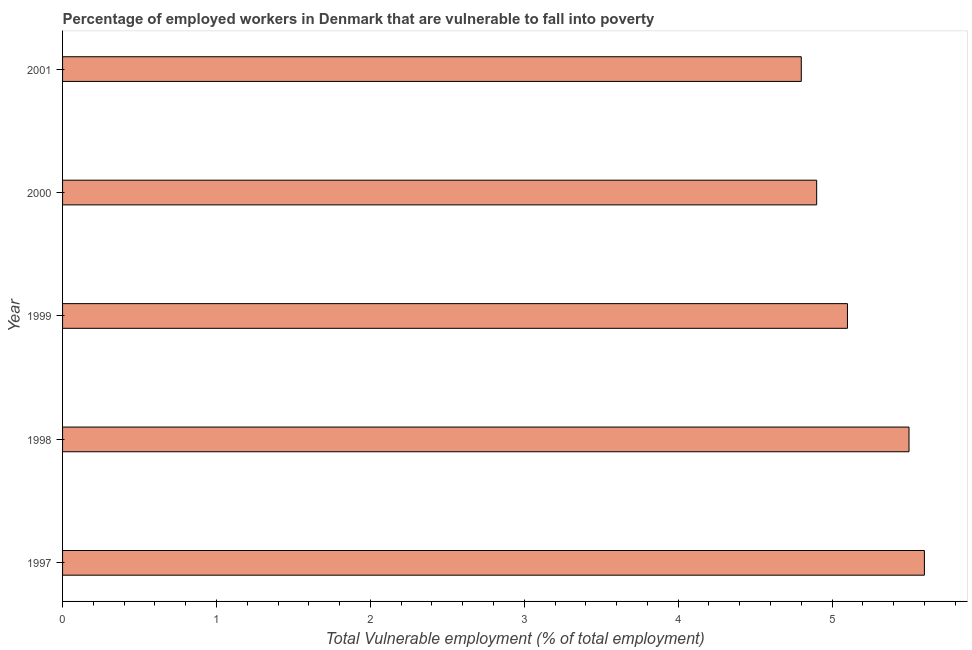What is the title of the graph?
Make the answer very short. Percentage of employed workers in Denmark that are vulnerable to fall into poverty. What is the label or title of the X-axis?
Give a very brief answer. Total Vulnerable employment (% of total employment). What is the total vulnerable employment in 1997?
Offer a terse response. 5.6. Across all years, what is the maximum total vulnerable employment?
Offer a very short reply. 5.6. Across all years, what is the minimum total vulnerable employment?
Keep it short and to the point. 4.8. In which year was the total vulnerable employment maximum?
Keep it short and to the point. 1997. In which year was the total vulnerable employment minimum?
Give a very brief answer. 2001. What is the sum of the total vulnerable employment?
Offer a terse response. 25.9. What is the average total vulnerable employment per year?
Your answer should be very brief. 5.18. What is the median total vulnerable employment?
Give a very brief answer. 5.1. Do a majority of the years between 1999 and 1997 (inclusive) have total vulnerable employment greater than 0.6 %?
Provide a succinct answer. Yes. What is the ratio of the total vulnerable employment in 2000 to that in 2001?
Your response must be concise. 1.02. Is the difference between the total vulnerable employment in 1997 and 1999 greater than the difference between any two years?
Make the answer very short. No. What is the difference between the highest and the second highest total vulnerable employment?
Ensure brevity in your answer.  0.1. Is the sum of the total vulnerable employment in 1998 and 2001 greater than the maximum total vulnerable employment across all years?
Your answer should be very brief. Yes. What is the difference between the highest and the lowest total vulnerable employment?
Your answer should be compact. 0.8. In how many years, is the total vulnerable employment greater than the average total vulnerable employment taken over all years?
Ensure brevity in your answer.  2. What is the Total Vulnerable employment (% of total employment) in 1997?
Your answer should be compact. 5.6. What is the Total Vulnerable employment (% of total employment) of 1998?
Offer a terse response. 5.5. What is the Total Vulnerable employment (% of total employment) in 1999?
Your answer should be very brief. 5.1. What is the Total Vulnerable employment (% of total employment) in 2000?
Your answer should be very brief. 4.9. What is the Total Vulnerable employment (% of total employment) in 2001?
Make the answer very short. 4.8. What is the difference between the Total Vulnerable employment (% of total employment) in 1997 and 1999?
Offer a terse response. 0.5. What is the difference between the Total Vulnerable employment (% of total employment) in 1998 and 2001?
Give a very brief answer. 0.7. What is the difference between the Total Vulnerable employment (% of total employment) in 1999 and 2001?
Your answer should be compact. 0.3. What is the ratio of the Total Vulnerable employment (% of total employment) in 1997 to that in 1998?
Ensure brevity in your answer.  1.02. What is the ratio of the Total Vulnerable employment (% of total employment) in 1997 to that in 1999?
Your answer should be very brief. 1.1. What is the ratio of the Total Vulnerable employment (% of total employment) in 1997 to that in 2000?
Give a very brief answer. 1.14. What is the ratio of the Total Vulnerable employment (% of total employment) in 1997 to that in 2001?
Provide a succinct answer. 1.17. What is the ratio of the Total Vulnerable employment (% of total employment) in 1998 to that in 1999?
Keep it short and to the point. 1.08. What is the ratio of the Total Vulnerable employment (% of total employment) in 1998 to that in 2000?
Give a very brief answer. 1.12. What is the ratio of the Total Vulnerable employment (% of total employment) in 1998 to that in 2001?
Make the answer very short. 1.15. What is the ratio of the Total Vulnerable employment (% of total employment) in 1999 to that in 2000?
Give a very brief answer. 1.04. What is the ratio of the Total Vulnerable employment (% of total employment) in 1999 to that in 2001?
Provide a short and direct response. 1.06. What is the ratio of the Total Vulnerable employment (% of total employment) in 2000 to that in 2001?
Your answer should be compact. 1.02. 